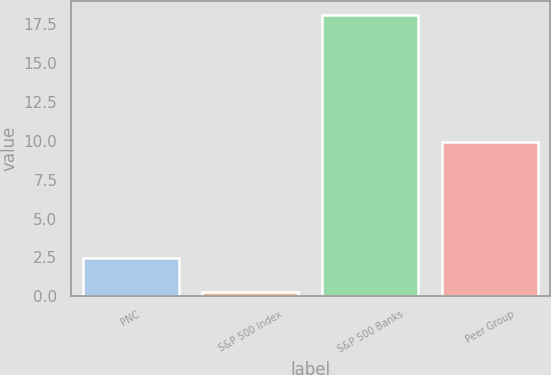<chart> <loc_0><loc_0><loc_500><loc_500><bar_chart><fcel>PNC<fcel>S&P 500 Index<fcel>S&P 500 Banks<fcel>Peer Group<nl><fcel>2.45<fcel>0.25<fcel>18.08<fcel>9.91<nl></chart> 